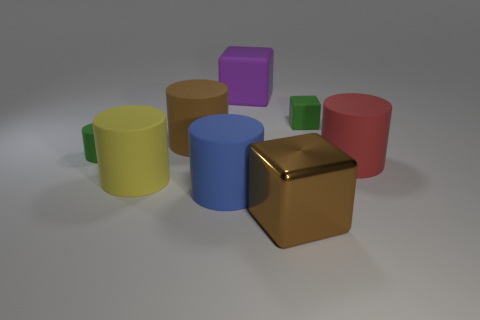Subtract all brown cylinders. How many cylinders are left? 4 Subtract all cyan cylinders. Subtract all gray blocks. How many cylinders are left? 5 Add 2 big red cylinders. How many objects exist? 10 Subtract all blocks. How many objects are left? 5 Subtract all big red matte balls. Subtract all big red matte things. How many objects are left? 7 Add 4 large things. How many large things are left? 10 Add 6 blocks. How many blocks exist? 9 Subtract 0 purple balls. How many objects are left? 8 